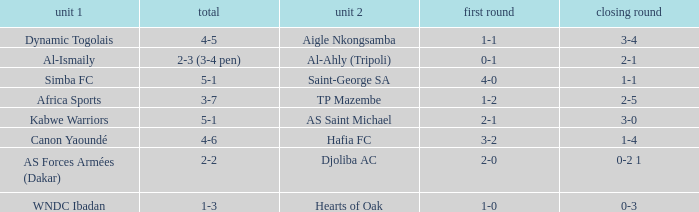When Kabwe Warriors (team 1) played, what was the result of the 1st leg? 2-1. 